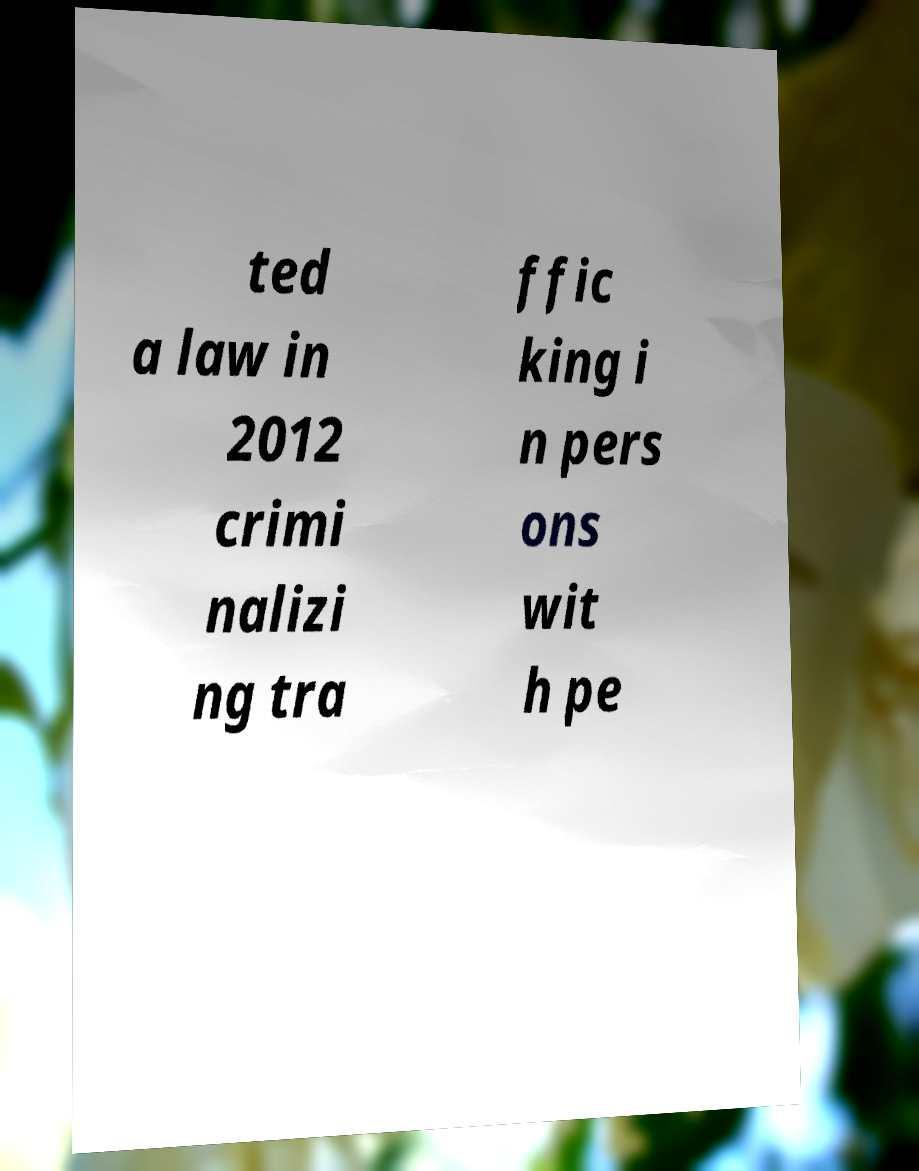What messages or text are displayed in this image? I need them in a readable, typed format. ted a law in 2012 crimi nalizi ng tra ffic king i n pers ons wit h pe 